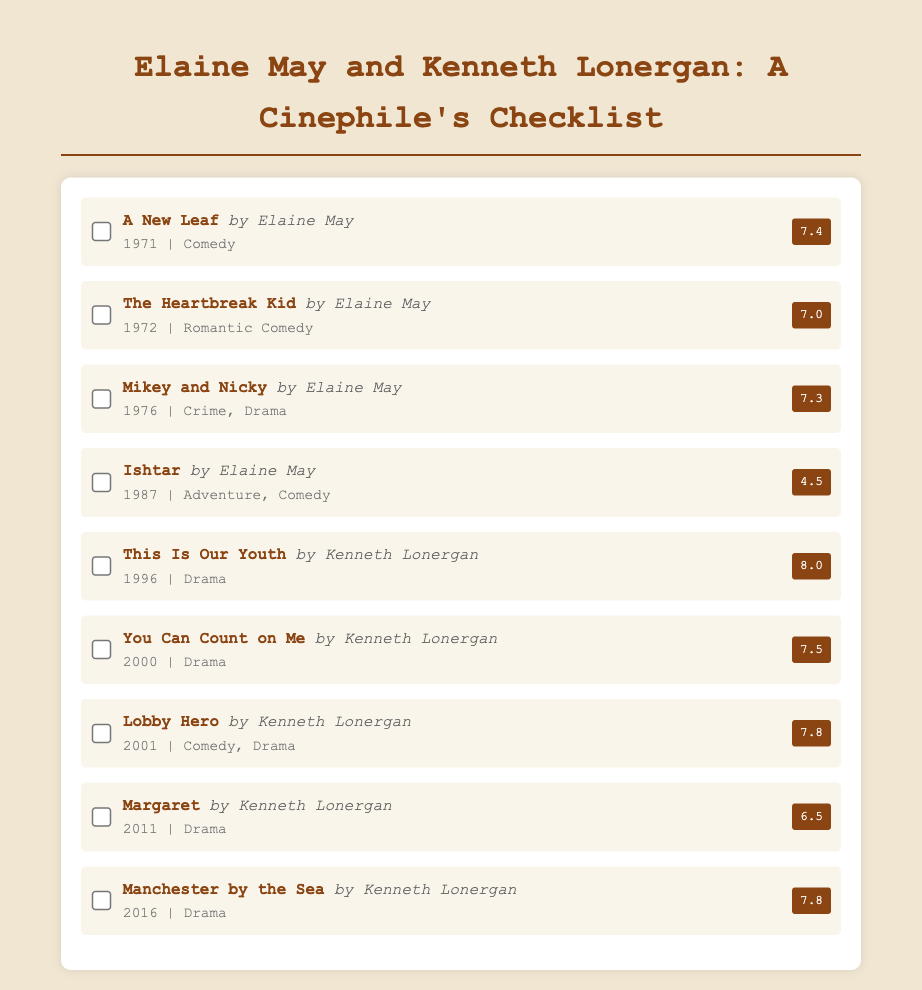What year was "A New Leaf" released? "A New Leaf" is documented to have been released in 1971.
Answer: 1971 Which film by Elaine May has the highest rating? The highest-rated film by Elaine May is "A New Leaf" with a rating of 7.4.
Answer: A New Leaf What genre is "Manchester by the Sea"? The genre of "Manchester by the Sea" is specified as Drama.
Answer: Drama Who directed "You Can Count on Me"? "You Can Count on Me" is directed by Kenneth Lonergan, making him the creator.
Answer: Kenneth Lonergan What is the total number of films listed in the checklist? The checklist includes a total of eight films.
Answer: 8 Which film was released in 1987? The film that was released in 1987 is "Ishtar."
Answer: Ishtar What rating did "Lobby Hero" receive? "Lobby Hero" received a rating of 7.8.
Answer: 7.8 Which creator has the lowest-rated film in this checklist? Elaine May has the lowest-rated film, "Ishtar," with a rating of 4.5.
Answer: Ishtar 